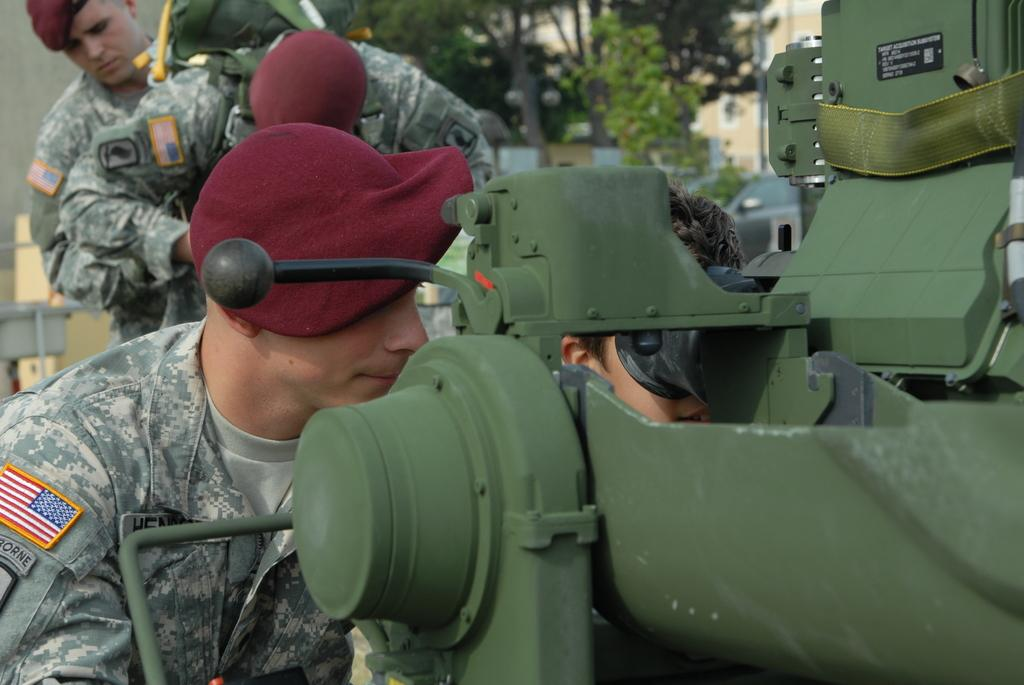What can be seen on the left side of the image? There are men on the left side of the image. What are the men wearing on their heads? The men are wearing dark red caps. What is located on the right side of the image? There is a machine on the right side of the image. What color is the machine? The machine is green in color. What type of vegetation is present in the middle of the image? There are green color trees in the middle of the image. Are there any beds visible in the image? No, there are no beds present in the image. What type of vegetable is being used as a prop in the image? There is no vegetable being used as a prop in the image. 